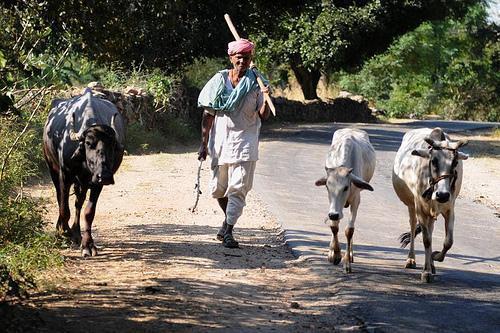How many cows are there?
Give a very brief answer. 3. How many white cows?
Give a very brief answer. 2. How many people are shown?
Give a very brief answer. 1. How many people are in the scene?
Give a very brief answer. 1. How many cattle are there?
Give a very brief answer. 3. 